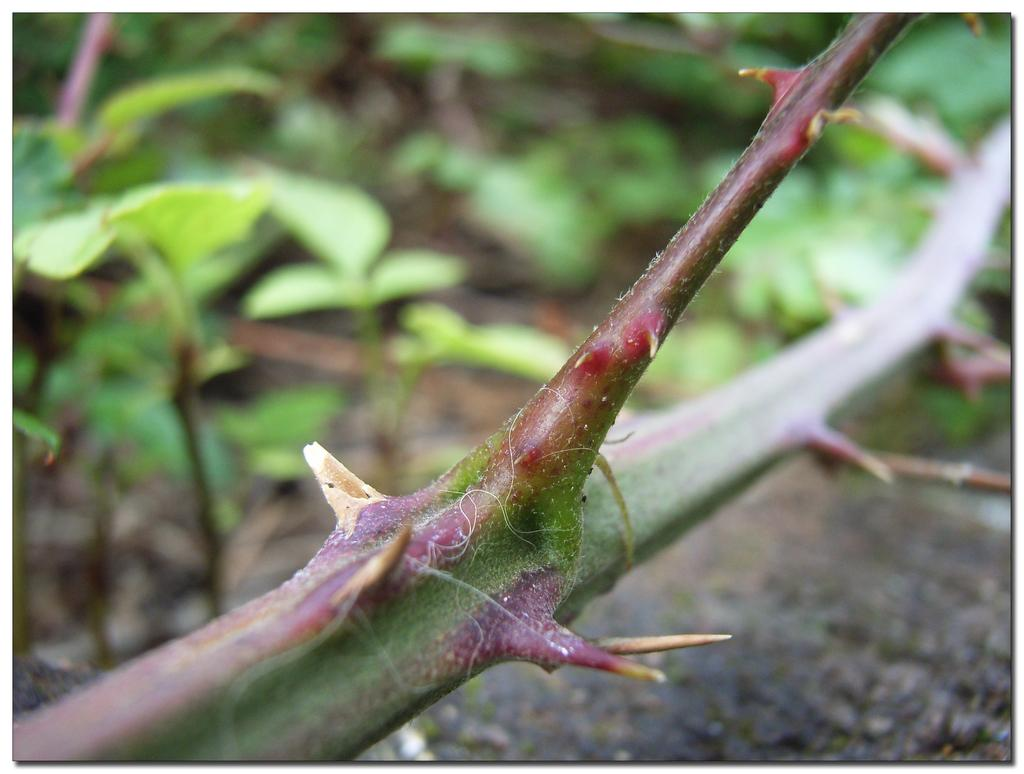What is the main object in the image? There is a branch in the image. What feature can be observed on the branch? There are spikes on the branch. What type of vegetation can be seen in the background of the image? Leaves are visible in the background of the image. What type of chalk is being used to draw on the branch in the image? There is no chalk or drawing present in the image; it only features a branch with spikes. What musical instrument can be heard playing in the background of the image? There is no musical instrument or sound present in the image; it only features a branch with spikes and leaves in the background. 